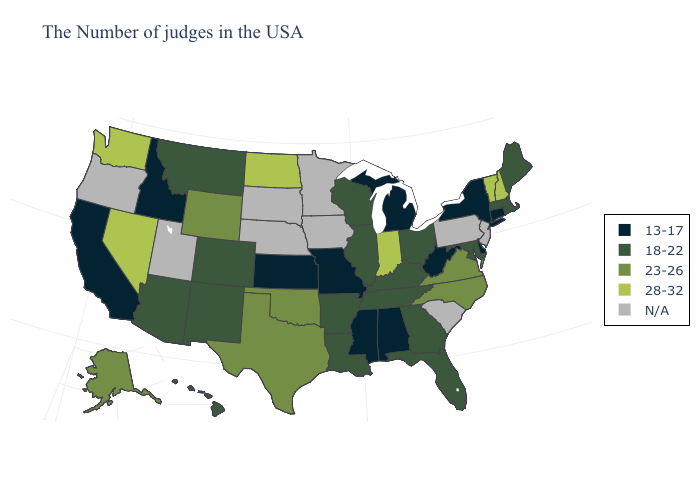What is the highest value in the USA?
Concise answer only. 28-32. What is the value of Ohio?
Write a very short answer. 18-22. Name the states that have a value in the range 23-26?
Be succinct. Virginia, North Carolina, Oklahoma, Texas, Wyoming, Alaska. Name the states that have a value in the range 28-32?
Write a very short answer. New Hampshire, Vermont, Indiana, North Dakota, Nevada, Washington. Name the states that have a value in the range 18-22?
Short answer required. Maine, Massachusetts, Rhode Island, Maryland, Ohio, Florida, Georgia, Kentucky, Tennessee, Wisconsin, Illinois, Louisiana, Arkansas, Colorado, New Mexico, Montana, Arizona, Hawaii. Does Ohio have the lowest value in the USA?
Concise answer only. No. Among the states that border New Jersey , which have the lowest value?
Write a very short answer. New York, Delaware. What is the value of South Dakota?
Give a very brief answer. N/A. What is the value of Maine?
Be succinct. 18-22. Name the states that have a value in the range 18-22?
Give a very brief answer. Maine, Massachusetts, Rhode Island, Maryland, Ohio, Florida, Georgia, Kentucky, Tennessee, Wisconsin, Illinois, Louisiana, Arkansas, Colorado, New Mexico, Montana, Arizona, Hawaii. What is the value of Tennessee?
Give a very brief answer. 18-22. Name the states that have a value in the range 28-32?
Be succinct. New Hampshire, Vermont, Indiana, North Dakota, Nevada, Washington. What is the value of North Dakota?
Concise answer only. 28-32. 